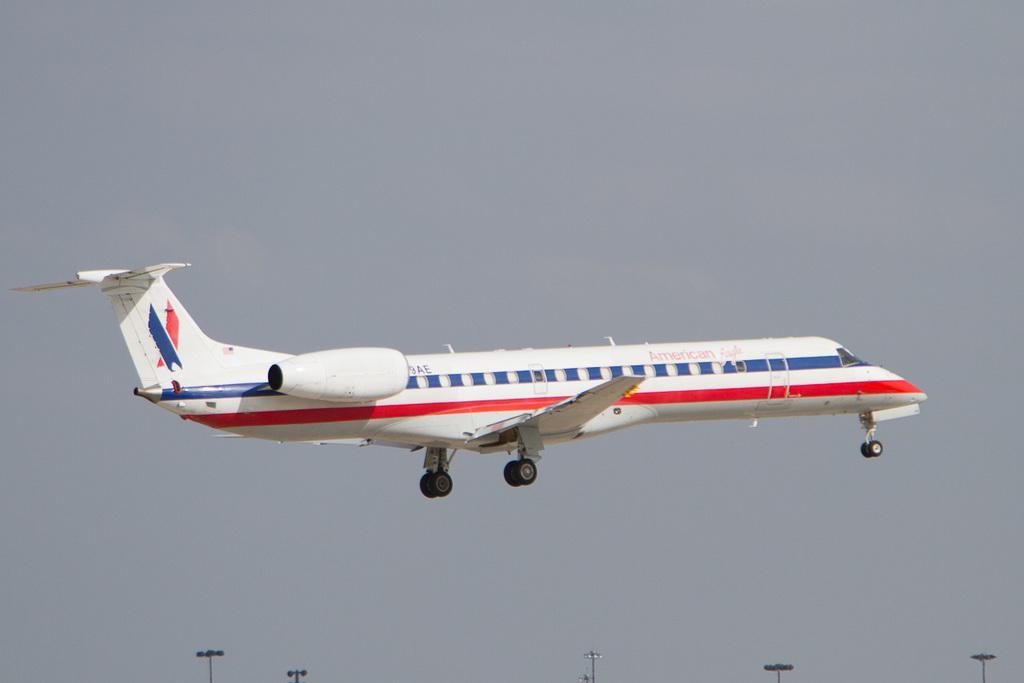Could you give a brief overview of what you see in this image? In this image we can see an airplane flying in the sky, also we can see the light poles. 